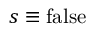<formula> <loc_0><loc_0><loc_500><loc_500>s \equiv f a l s e</formula> 